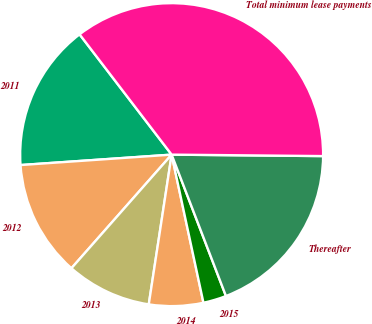<chart> <loc_0><loc_0><loc_500><loc_500><pie_chart><fcel>2011<fcel>2012<fcel>2013<fcel>2014<fcel>2015<fcel>Thereafter<fcel>Total minimum lease payments<nl><fcel>15.7%<fcel>12.4%<fcel>9.09%<fcel>5.78%<fcel>2.47%<fcel>19.01%<fcel>35.55%<nl></chart> 